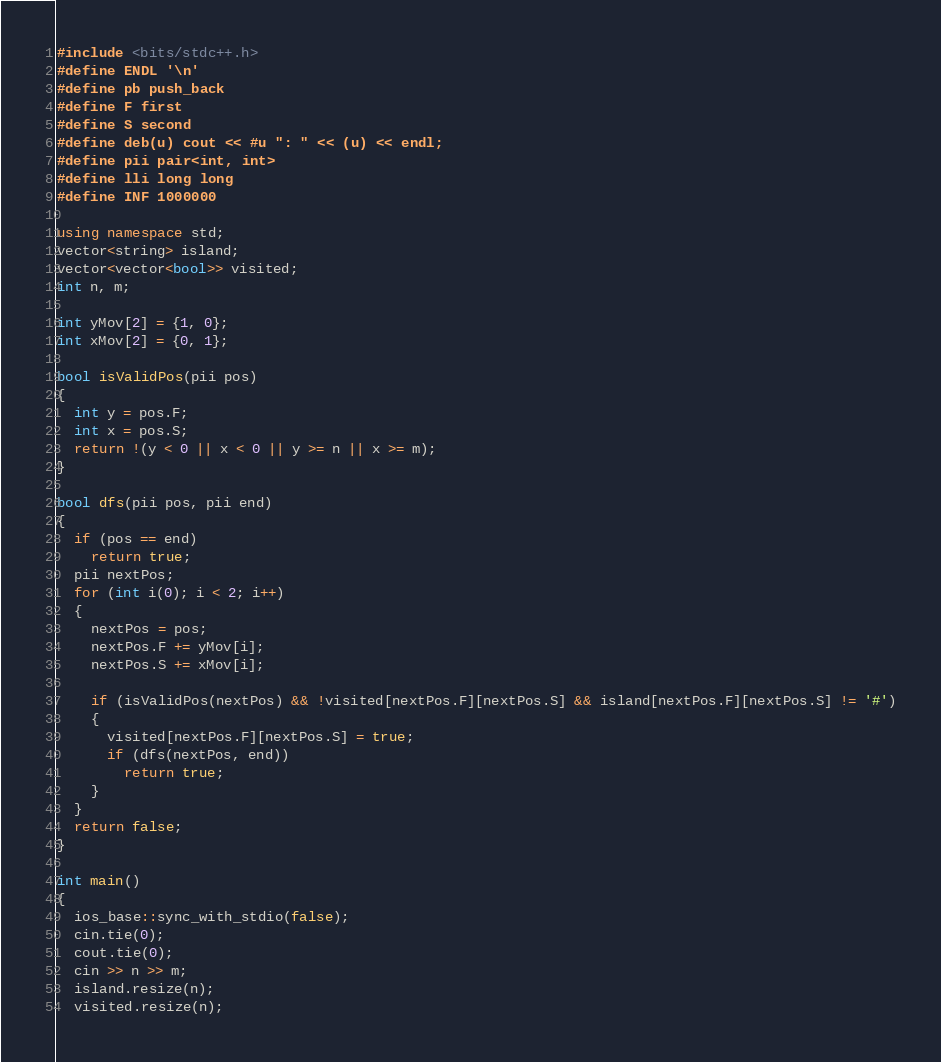Convert code to text. <code><loc_0><loc_0><loc_500><loc_500><_C++_>#include <bits/stdc++.h>
#define ENDL '\n'
#define pb push_back
#define F first
#define S second
#define deb(u) cout << #u ": " << (u) << endl;
#define pii pair<int, int>
#define lli long long
#define INF 1000000

using namespace std;
vector<string> island;
vector<vector<bool>> visited;
int n, m;

int yMov[2] = {1, 0};
int xMov[2] = {0, 1};

bool isValidPos(pii pos)
{
  int y = pos.F;
  int x = pos.S;
  return !(y < 0 || x < 0 || y >= n || x >= m);
}

bool dfs(pii pos, pii end)
{
  if (pos == end)
    return true;
  pii nextPos;
  for (int i(0); i < 2; i++)
  {
    nextPos = pos;
    nextPos.F += yMov[i];
    nextPos.S += xMov[i];

    if (isValidPos(nextPos) && !visited[nextPos.F][nextPos.S] && island[nextPos.F][nextPos.S] != '#')
    {
      visited[nextPos.F][nextPos.S] = true;
      if (dfs(nextPos, end))
        return true;
    }
  }
  return false;
}

int main()
{
  ios_base::sync_with_stdio(false);
  cin.tie(0);
  cout.tie(0);
  cin >> n >> m;
  island.resize(n);
  visited.resize(n);</code> 